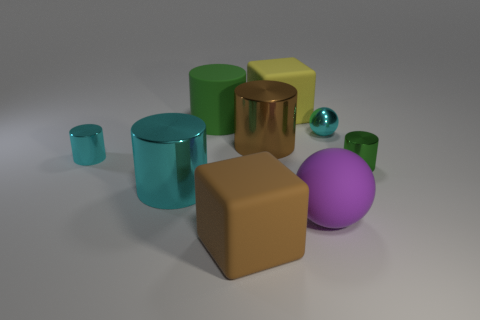Is the number of brown metal things right of the tiny green shiny cylinder less than the number of large gray things?
Offer a terse response. No. Are there fewer brown matte blocks than tiny metallic cubes?
Keep it short and to the point. No. There is a cube that is behind the tiny cyan shiny object that is to the right of the large brown matte cube; what is its color?
Offer a very short reply. Yellow. What is the brown thing that is in front of the brown cylinder that is to the right of the large metallic cylinder in front of the green metallic cylinder made of?
Your answer should be compact. Rubber. Is the size of the brown thing behind the purple sphere the same as the large cyan metal cylinder?
Offer a terse response. Yes. There is a large cube to the right of the brown matte object; what material is it?
Provide a short and direct response. Rubber. Is the number of big green objects greater than the number of tiny blue rubber blocks?
Your answer should be compact. Yes. How many things are big rubber blocks in front of the green rubber cylinder or tiny objects?
Offer a very short reply. 4. What number of matte cylinders are in front of the purple object in front of the large yellow matte thing?
Offer a very short reply. 0. There is a green thing that is in front of the rubber cylinder that is behind the big object that is right of the big yellow rubber thing; how big is it?
Offer a terse response. Small. 